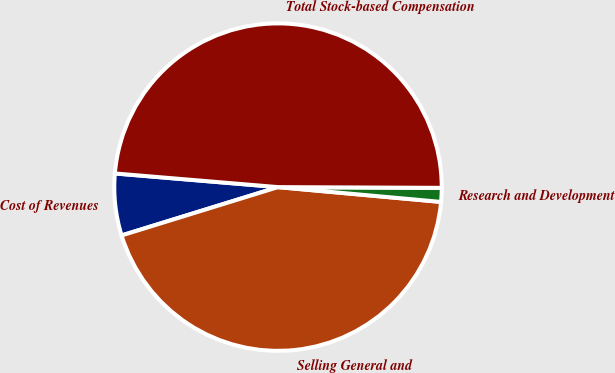<chart> <loc_0><loc_0><loc_500><loc_500><pie_chart><fcel>Cost of Revenues<fcel>Selling General and<fcel>Research and Development<fcel>Total Stock-based Compensation<nl><fcel>6.1%<fcel>43.79%<fcel>1.37%<fcel>48.74%<nl></chart> 